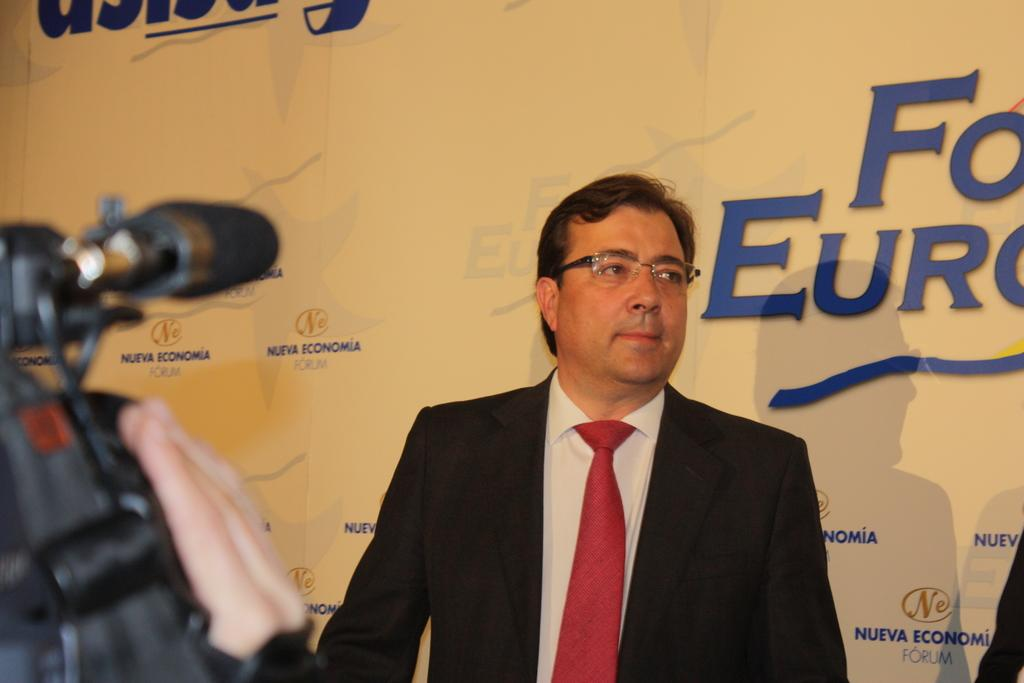Who is the main subject in the image? A: There is a man in the image. What is the man standing in front of? The man is standing in front of a banner. What is the purpose of the camera in the image? The camera is focusing on the man. What might be happening in the image? The situation appears to be an interview. What is the limit of the airplane in the image? There is no airplane present in the image, so there is no limit to discuss. 